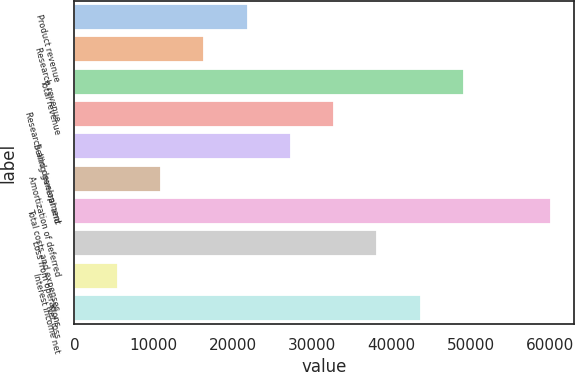Convert chart. <chart><loc_0><loc_0><loc_500><loc_500><bar_chart><fcel>Product revenue<fcel>Research revenue<fcel>Total revenue<fcel>Research and development<fcel>Selling general and<fcel>Amortization of deferred<fcel>Total costs and expenses<fcel>Loss from operations<fcel>Interest income net<fcel>Net loss<nl><fcel>21863.3<fcel>16397.7<fcel>49191.4<fcel>32794.6<fcel>27329<fcel>10932.1<fcel>60122.6<fcel>38260.2<fcel>5466.47<fcel>43725.8<nl></chart> 